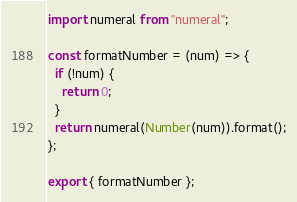Convert code to text. <code><loc_0><loc_0><loc_500><loc_500><_JavaScript_>import numeral from "numeral";

const formatNumber = (num) => {
  if (!num) {
    return 0;
  }
  return numeral(Number(num)).format();
};

export { formatNumber };
</code> 